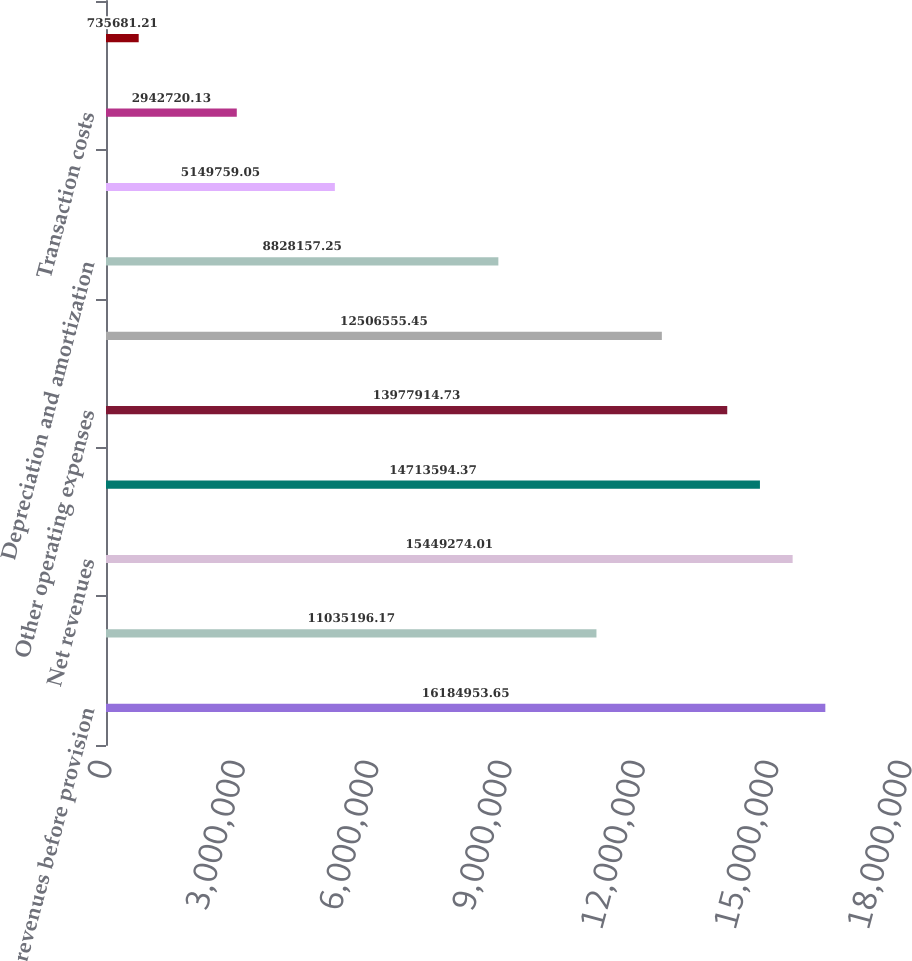Convert chart. <chart><loc_0><loc_0><loc_500><loc_500><bar_chart><fcel>Net revenues before provision<fcel>Less Provision for doubtful<fcel>Net revenues<fcel>Salaries wages and benefits<fcel>Other operating expenses<fcel>Supplies expense<fcel>Depreciation and amortization<fcel>Lease and rental expense<fcel>Transaction costs<fcel>Electronic health records<nl><fcel>1.6185e+07<fcel>1.10352e+07<fcel>1.54493e+07<fcel>1.47136e+07<fcel>1.39779e+07<fcel>1.25066e+07<fcel>8.82816e+06<fcel>5.14976e+06<fcel>2.94272e+06<fcel>735681<nl></chart> 